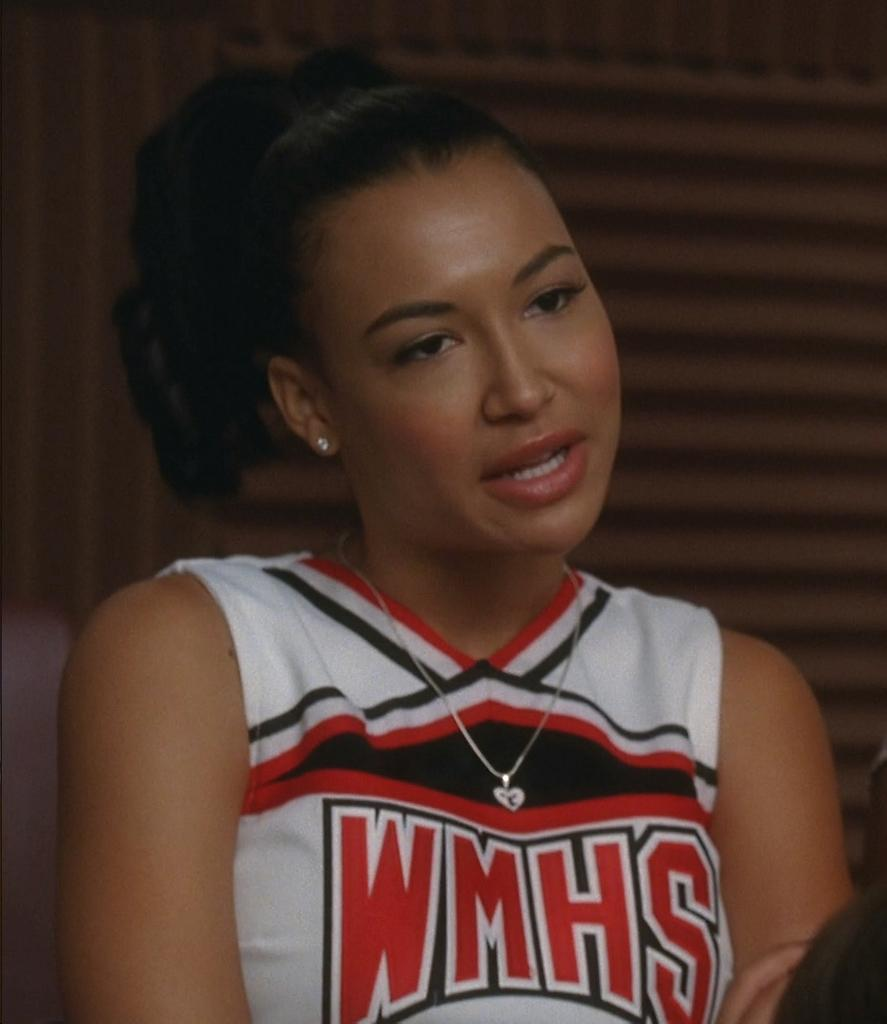Provide a one-sentence caption for the provided image. A cheerleader from WMHS is wearing a red, white, and black uniform. 